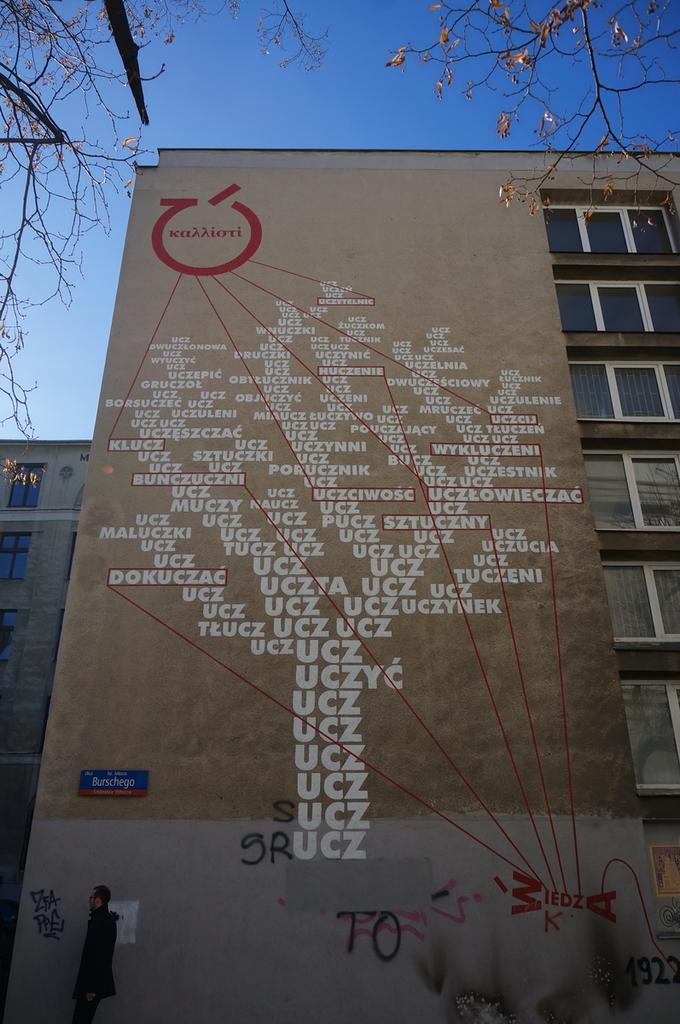Please provide a concise description of this image. There is one man standing at the bottom of this image and there is a building in the background. We can see there is some text written on it, and there are some windows on the right side of this image. There is a sky at the top of this image. We can see stems and leaves of a tree at the top of this image. 